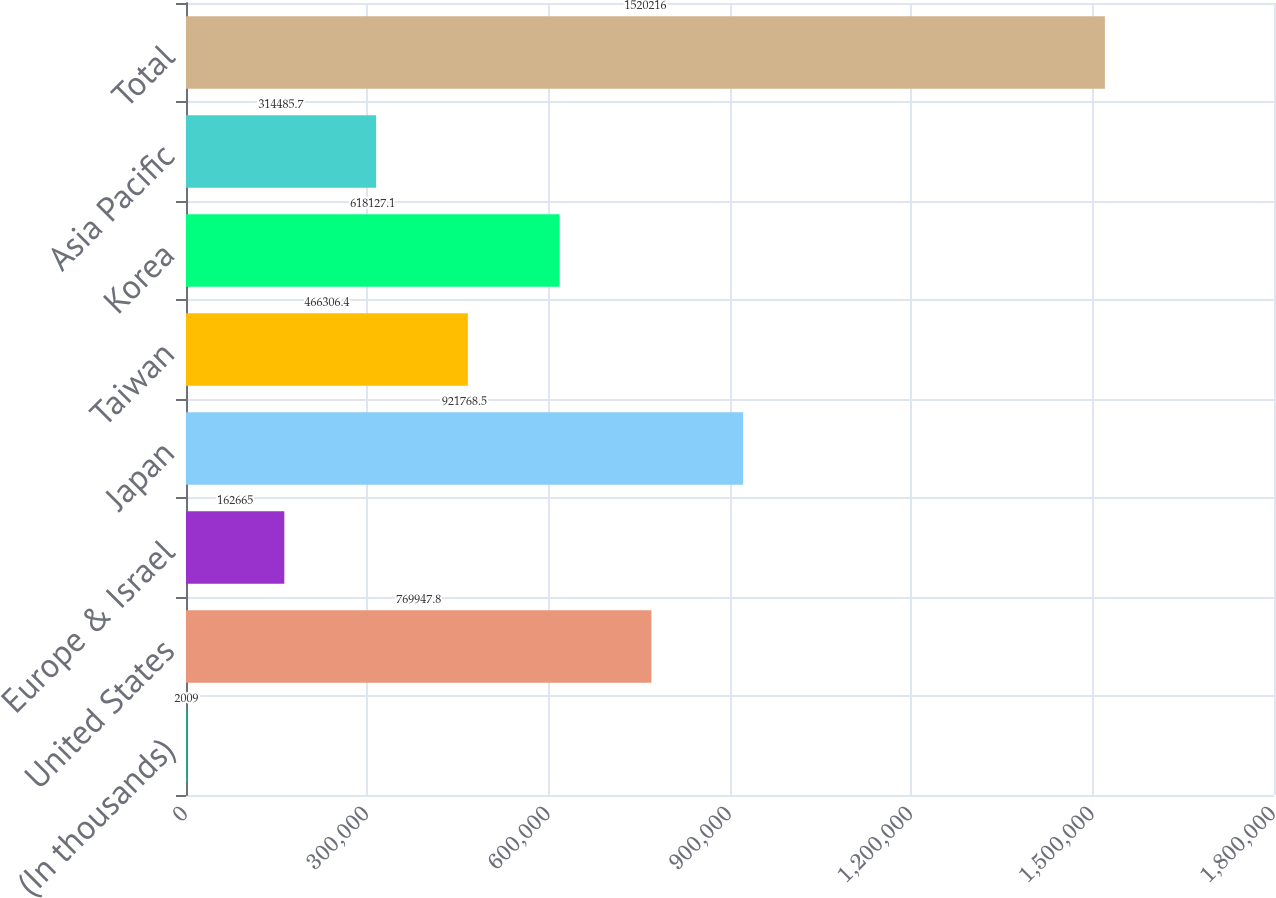Convert chart to OTSL. <chart><loc_0><loc_0><loc_500><loc_500><bar_chart><fcel>(In thousands)<fcel>United States<fcel>Europe & Israel<fcel>Japan<fcel>Taiwan<fcel>Korea<fcel>Asia Pacific<fcel>Total<nl><fcel>2009<fcel>769948<fcel>162665<fcel>921768<fcel>466306<fcel>618127<fcel>314486<fcel>1.52022e+06<nl></chart> 